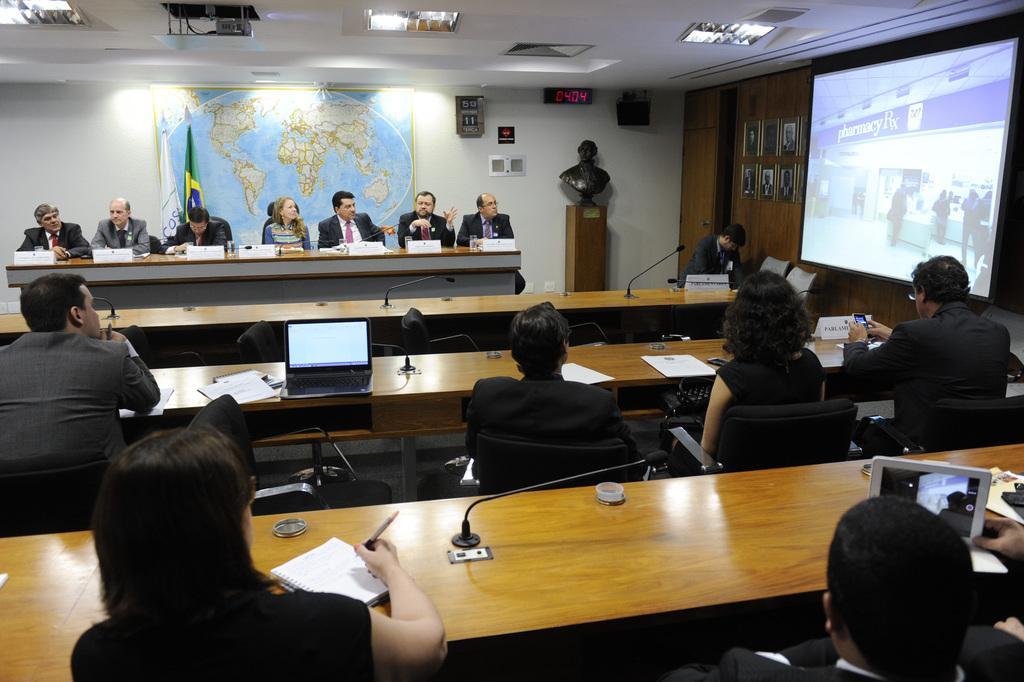Could you give a brief overview of what you see in this image? In this image there are group of people sitting on the chair in front of the table on which a laptop, papers, books, bottle and name plates etc., are kept. A roof top is white in color on which light is mounted. In the right a screen is visible. The walls are white in color on which poster is there. Below that flag is there. In the middle a table is there on which statue is there. This image is taken inside a hall. 